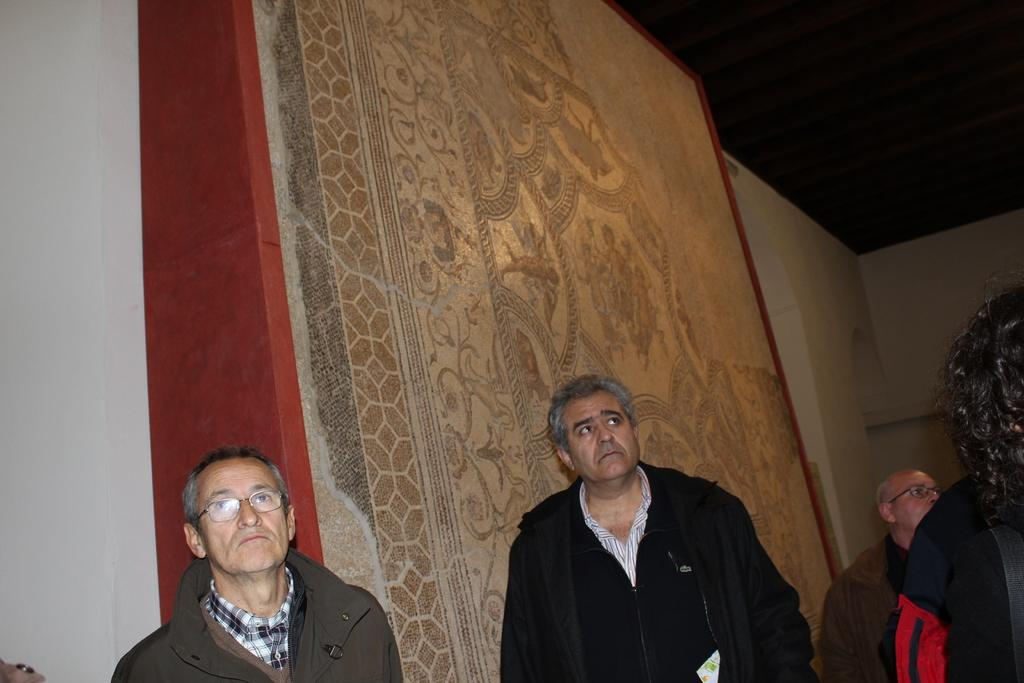How many people are in the image? There is a group of people in the image. What are the people in the image doing? The people are standing. What can be seen in the background of the image? There is a wall in the background of the image. What is on the wall in the image? There is some art visible on the wall. What is the value of the thing being protested in the image? There is no protest or thing being protested in the image; it simply shows a group of people standing with a wall and art in the background. 